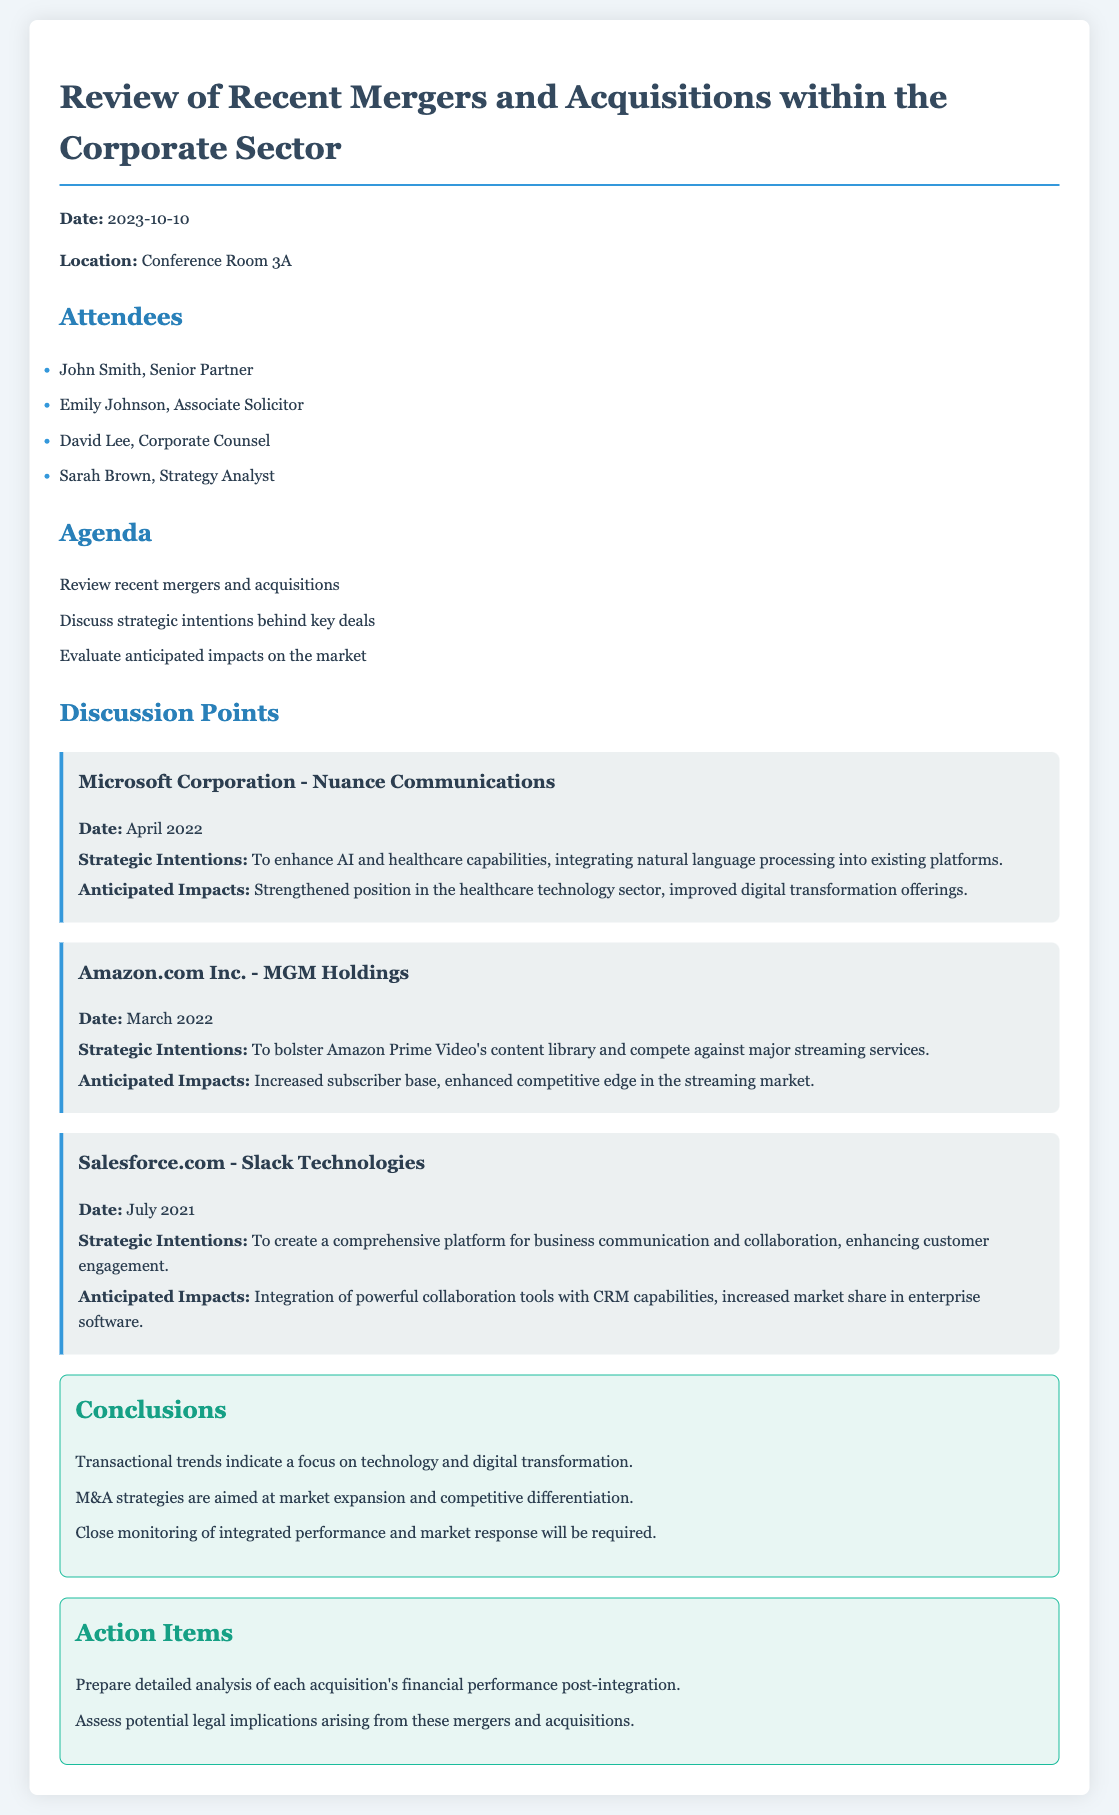What is the date of the meeting? The date of the meeting is mentioned at the beginning of the document.
Answer: 2023-10-10 Who attended the meeting as the Senior Partner? The document lists attendees, and John Smith is identified as the Senior Partner.
Answer: John Smith What company did Amazon acquire? The discussion points mention the acquisition of MGM Holdings by Amazon.com Inc.
Answer: MGM Holdings What is the anticipated impact of Microsoft's acquisition of Nuance Communications? The anticipated impacts are specifically listed for each acquisition, noting a strengthened position in healthcare technology.
Answer: Strengthened position in the healthcare technology sector What strategic intention is associated with Salesforce's acquisition of Slack Technologies? The document outlines strategic intentions for various acquisitions, specifically mentioning business communication and collaboration enhancement.
Answer: Create a comprehensive platform for business communication and collaboration What is one of the conclusions drawn in the meeting? Conclusions are summarized in a list within the minutes, reflecting overarching themes discussed.
Answer: Transactional trends indicate a focus on technology and digital transformation What action item involves the financial performance of acquisitions? The action items outline specific tasks required following the discussion, including a focus on financial performance post-integration.
Answer: Prepare detailed analysis of each acquisition's financial performance post-integration What was discussed regarding Amazon Prime Video? The agenda includes discussing strategic intentions related to acquisitions, specifically focusing on content library expansion for Amazon Prime Video.
Answer: To bolster Amazon Prime Video's content library and compete against major streaming services 